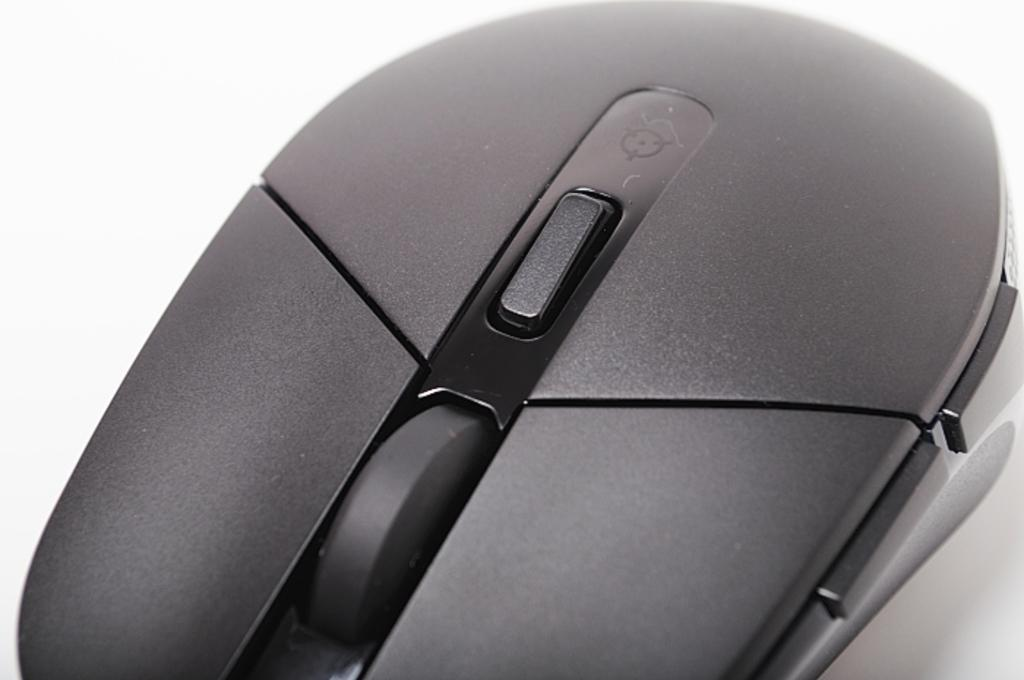What is the main subject of the image? There is a mouse in the image. What color is the background of the image? The background of the image is white. Can you see any wishes or wealth in the image? There is no reference to wishes or wealth in the image; it features a mouse against a white background. Is there a cobweb present in the image? There is no mention of a cobweb in the provided facts, so it cannot be determined from the image. 